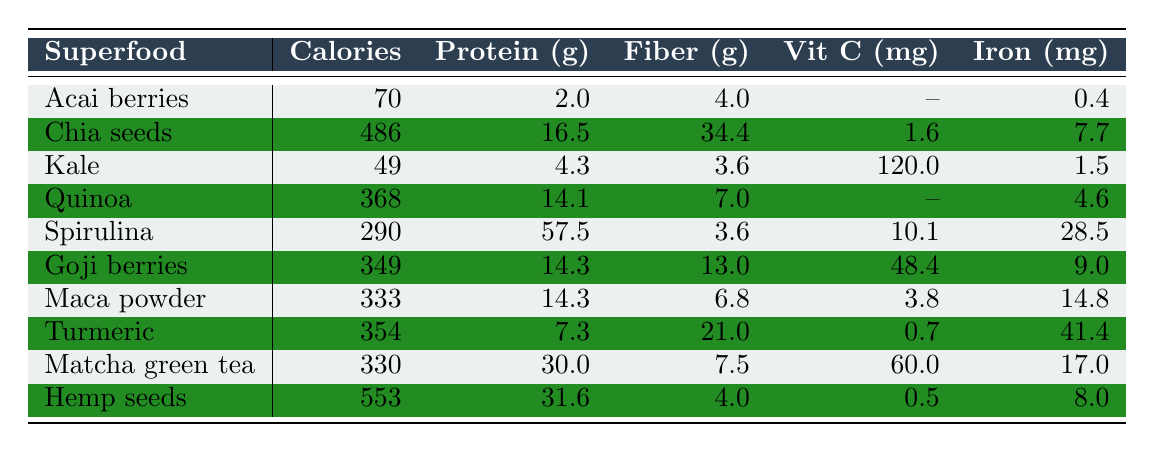What is the protein content of Spirulina? The table lists Spirulina with a protein content of 57.5 grams per 100 grams.
Answer: 57.5 grams Which superfood has the highest antioxidant value according to the table? The antioxidant value for Chia seeds is 1888 ORAC, while the highest value appears next to Spirulina at 24000 ORAC. Thus, Spirulina has the highest antioxidant value.
Answer: Spirulina What is the total calcium content of both Kale and Quinoa combined? The calcium content for Kale is 150 mg and for Quinoa is 47 mg. Adding these together gives 150 + 47 = 197 mg.
Answer: 197 mg Is it true that Goji berries have more fiber than Chia seeds? Goji berries contain 13.0 grams of fiber, while Chia seeds contain 34.4 grams. Therefore, the statement is false.
Answer: No What is the average calorie content of the superfoods listed in the table? The total calorie content is calculated by summing the calorie values: 70 + 486 + 49 + 368 + 290 + 349 + 333 + 354 + 330 + 553 = 2810. With 10 superfoods, the average is 2810 / 10 = 281.
Answer: 281 calories Which superfood has the lowest protein content? The table shows that Acai berries have the lowest protein content at 2 grams per 100 grams, compared to others which have higher values.
Answer: Acai berries How much Vitamin C does Kale provide compared to Goji berries? Kale provides 120 mg of Vitamin C, while Goji berries provide 48.4 mg. Kale has significantly more Vitamin C than Goji berries.
Answer: Kale has more Vitamin C Which superfood has the highest iron content? The highest iron content is found in Spirulina at 28.5 mg per 100 grams, as observed in the table.
Answer: Spirulina If you were to compare the fiber content of Maca powder and Turmeric, which one has more? Maca powder has a fiber content of 6.8 grams while Turmeric has 21 grams. Comparing these values shows Turmeric has more fiber.
Answer: Turmeric What is the difference in magnesium content between Chia seeds and Hemp seeds? Chia seeds contain 335 mg of magnesium, while Hemp seeds have 700 mg. The difference is calculated as 700 - 335 = 365 mg.
Answer: 365 mg Which superfood has the lowest calorie count and what is it? Kale has the lowest calorie count at 49 calories per 100 grams, based on the values presented in the table.
Answer: Kale at 49 calories 